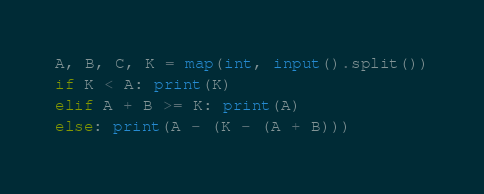Convert code to text. <code><loc_0><loc_0><loc_500><loc_500><_Python_>A, B, C, K = map(int, input().split())
if K < A: print(K)
elif A + B >= K: print(A)
else: print(A - (K - (A + B)))</code> 